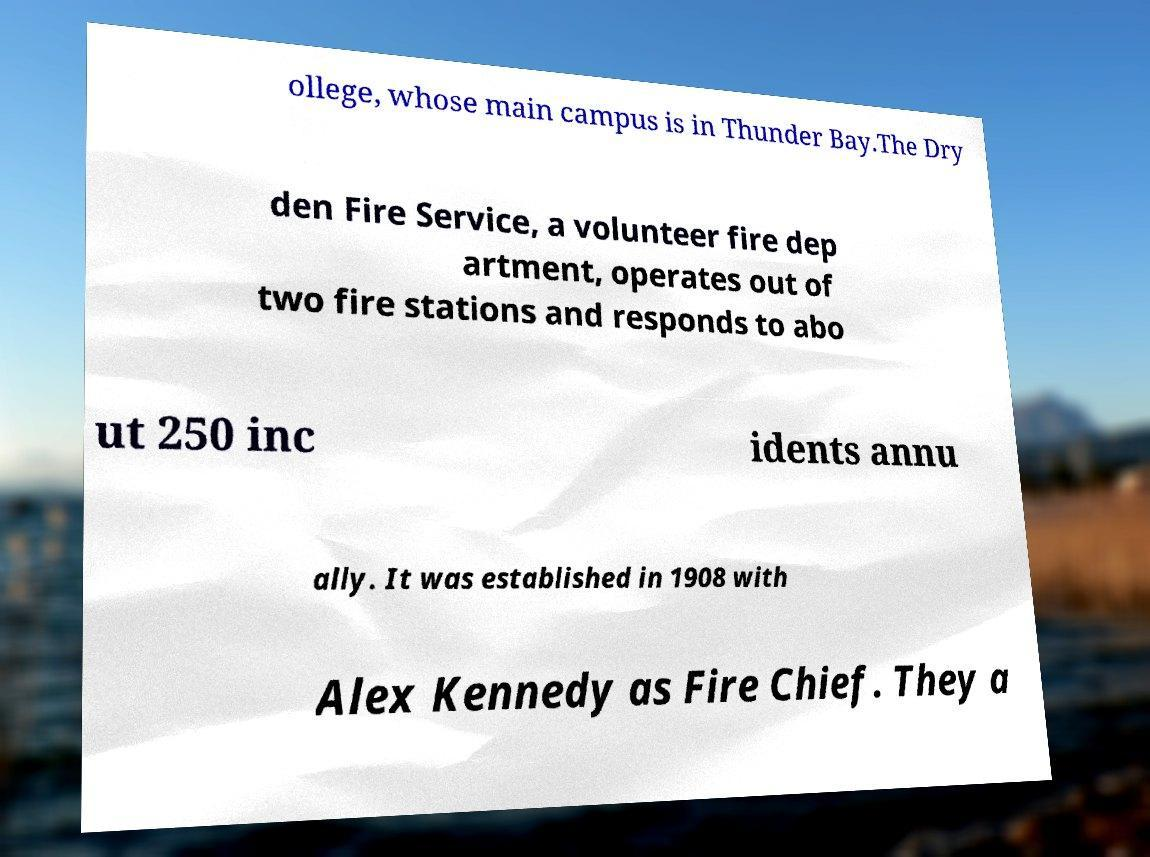Can you read and provide the text displayed in the image?This photo seems to have some interesting text. Can you extract and type it out for me? ollege, whose main campus is in Thunder Bay.The Dry den Fire Service, a volunteer fire dep artment, operates out of two fire stations and responds to abo ut 250 inc idents annu ally. It was established in 1908 with Alex Kennedy as Fire Chief. They a 